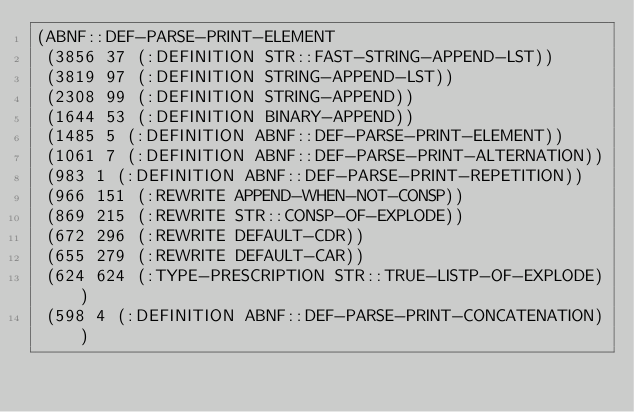<code> <loc_0><loc_0><loc_500><loc_500><_Lisp_>(ABNF::DEF-PARSE-PRINT-ELEMENT
 (3856 37 (:DEFINITION STR::FAST-STRING-APPEND-LST))
 (3819 97 (:DEFINITION STRING-APPEND-LST))
 (2308 99 (:DEFINITION STRING-APPEND))
 (1644 53 (:DEFINITION BINARY-APPEND))
 (1485 5 (:DEFINITION ABNF::DEF-PARSE-PRINT-ELEMENT))
 (1061 7 (:DEFINITION ABNF::DEF-PARSE-PRINT-ALTERNATION))
 (983 1 (:DEFINITION ABNF::DEF-PARSE-PRINT-REPETITION))
 (966 151 (:REWRITE APPEND-WHEN-NOT-CONSP))
 (869 215 (:REWRITE STR::CONSP-OF-EXPLODE))
 (672 296 (:REWRITE DEFAULT-CDR))
 (655 279 (:REWRITE DEFAULT-CAR))
 (624 624 (:TYPE-PRESCRIPTION STR::TRUE-LISTP-OF-EXPLODE))
 (598 4 (:DEFINITION ABNF::DEF-PARSE-PRINT-CONCATENATION))</code> 